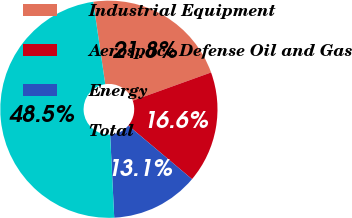Convert chart. <chart><loc_0><loc_0><loc_500><loc_500><pie_chart><fcel>Industrial Equipment<fcel>Aerospace Defense Oil and Gas<fcel>Energy<fcel>Total<nl><fcel>21.81%<fcel>16.63%<fcel>13.09%<fcel>48.47%<nl></chart> 